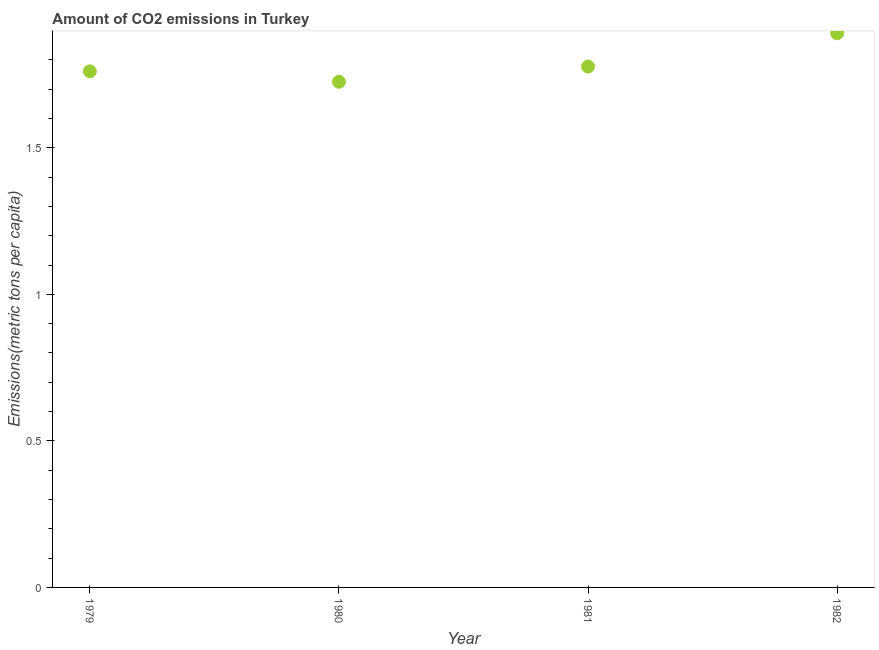What is the amount of co2 emissions in 1981?
Your response must be concise. 1.78. Across all years, what is the maximum amount of co2 emissions?
Offer a very short reply. 1.89. Across all years, what is the minimum amount of co2 emissions?
Keep it short and to the point. 1.73. What is the sum of the amount of co2 emissions?
Your response must be concise. 7.16. What is the difference between the amount of co2 emissions in 1981 and 1982?
Keep it short and to the point. -0.11. What is the average amount of co2 emissions per year?
Give a very brief answer. 1.79. What is the median amount of co2 emissions?
Ensure brevity in your answer.  1.77. In how many years, is the amount of co2 emissions greater than 1.4 metric tons per capita?
Give a very brief answer. 4. Do a majority of the years between 1982 and 1981 (inclusive) have amount of co2 emissions greater than 0.4 metric tons per capita?
Provide a succinct answer. No. What is the ratio of the amount of co2 emissions in 1979 to that in 1982?
Provide a short and direct response. 0.93. What is the difference between the highest and the second highest amount of co2 emissions?
Keep it short and to the point. 0.11. Is the sum of the amount of co2 emissions in 1979 and 1980 greater than the maximum amount of co2 emissions across all years?
Give a very brief answer. Yes. What is the difference between the highest and the lowest amount of co2 emissions?
Provide a succinct answer. 0.17. How many dotlines are there?
Make the answer very short. 1. What is the difference between two consecutive major ticks on the Y-axis?
Offer a very short reply. 0.5. Are the values on the major ticks of Y-axis written in scientific E-notation?
Ensure brevity in your answer.  No. Does the graph contain any zero values?
Provide a succinct answer. No. Does the graph contain grids?
Offer a terse response. No. What is the title of the graph?
Your answer should be very brief. Amount of CO2 emissions in Turkey. What is the label or title of the X-axis?
Your answer should be very brief. Year. What is the label or title of the Y-axis?
Your answer should be very brief. Emissions(metric tons per capita). What is the Emissions(metric tons per capita) in 1979?
Offer a very short reply. 1.76. What is the Emissions(metric tons per capita) in 1980?
Provide a short and direct response. 1.73. What is the Emissions(metric tons per capita) in 1981?
Give a very brief answer. 1.78. What is the Emissions(metric tons per capita) in 1982?
Offer a terse response. 1.89. What is the difference between the Emissions(metric tons per capita) in 1979 and 1980?
Give a very brief answer. 0.04. What is the difference between the Emissions(metric tons per capita) in 1979 and 1981?
Your answer should be very brief. -0.02. What is the difference between the Emissions(metric tons per capita) in 1979 and 1982?
Keep it short and to the point. -0.13. What is the difference between the Emissions(metric tons per capita) in 1980 and 1981?
Give a very brief answer. -0.05. What is the difference between the Emissions(metric tons per capita) in 1980 and 1982?
Your answer should be compact. -0.17. What is the difference between the Emissions(metric tons per capita) in 1981 and 1982?
Provide a succinct answer. -0.11. What is the ratio of the Emissions(metric tons per capita) in 1980 to that in 1982?
Provide a short and direct response. 0.91. What is the ratio of the Emissions(metric tons per capita) in 1981 to that in 1982?
Give a very brief answer. 0.94. 